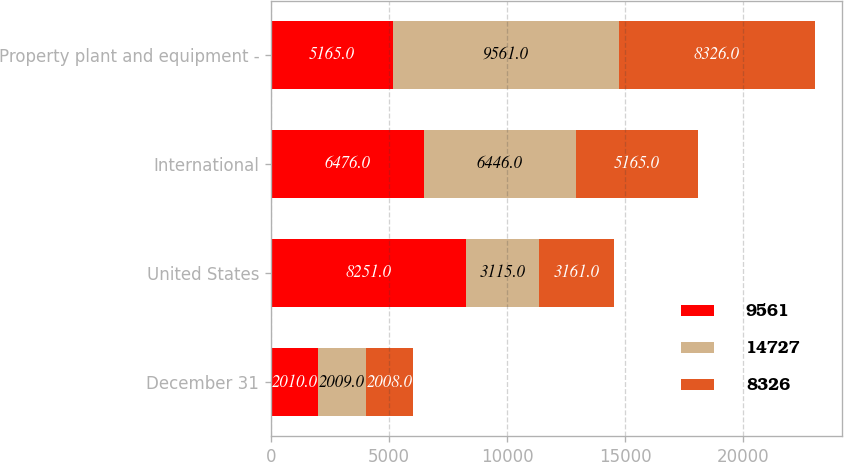Convert chart. <chart><loc_0><loc_0><loc_500><loc_500><stacked_bar_chart><ecel><fcel>December 31<fcel>United States<fcel>International<fcel>Property plant and equipment -<nl><fcel>9561<fcel>2010<fcel>8251<fcel>6476<fcel>5165<nl><fcel>14727<fcel>2009<fcel>3115<fcel>6446<fcel>9561<nl><fcel>8326<fcel>2008<fcel>3161<fcel>5165<fcel>8326<nl></chart> 